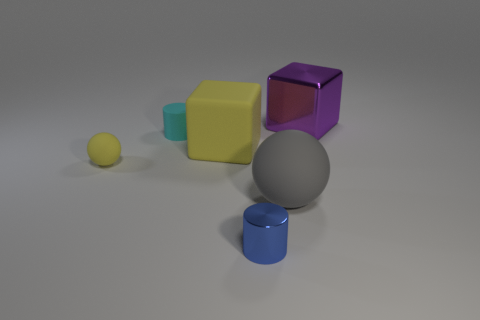Could you describe the lighting in the scene? Certainly. The lighting in the scene seems to be overhead, possibly simulating a soft, diffused light source, as evidenced by the soft shadows beneath the objects. There are no harsh shadows or bright highlights, which creates an impression of a cloudy day or a room with well-diffused ambient lighting. 